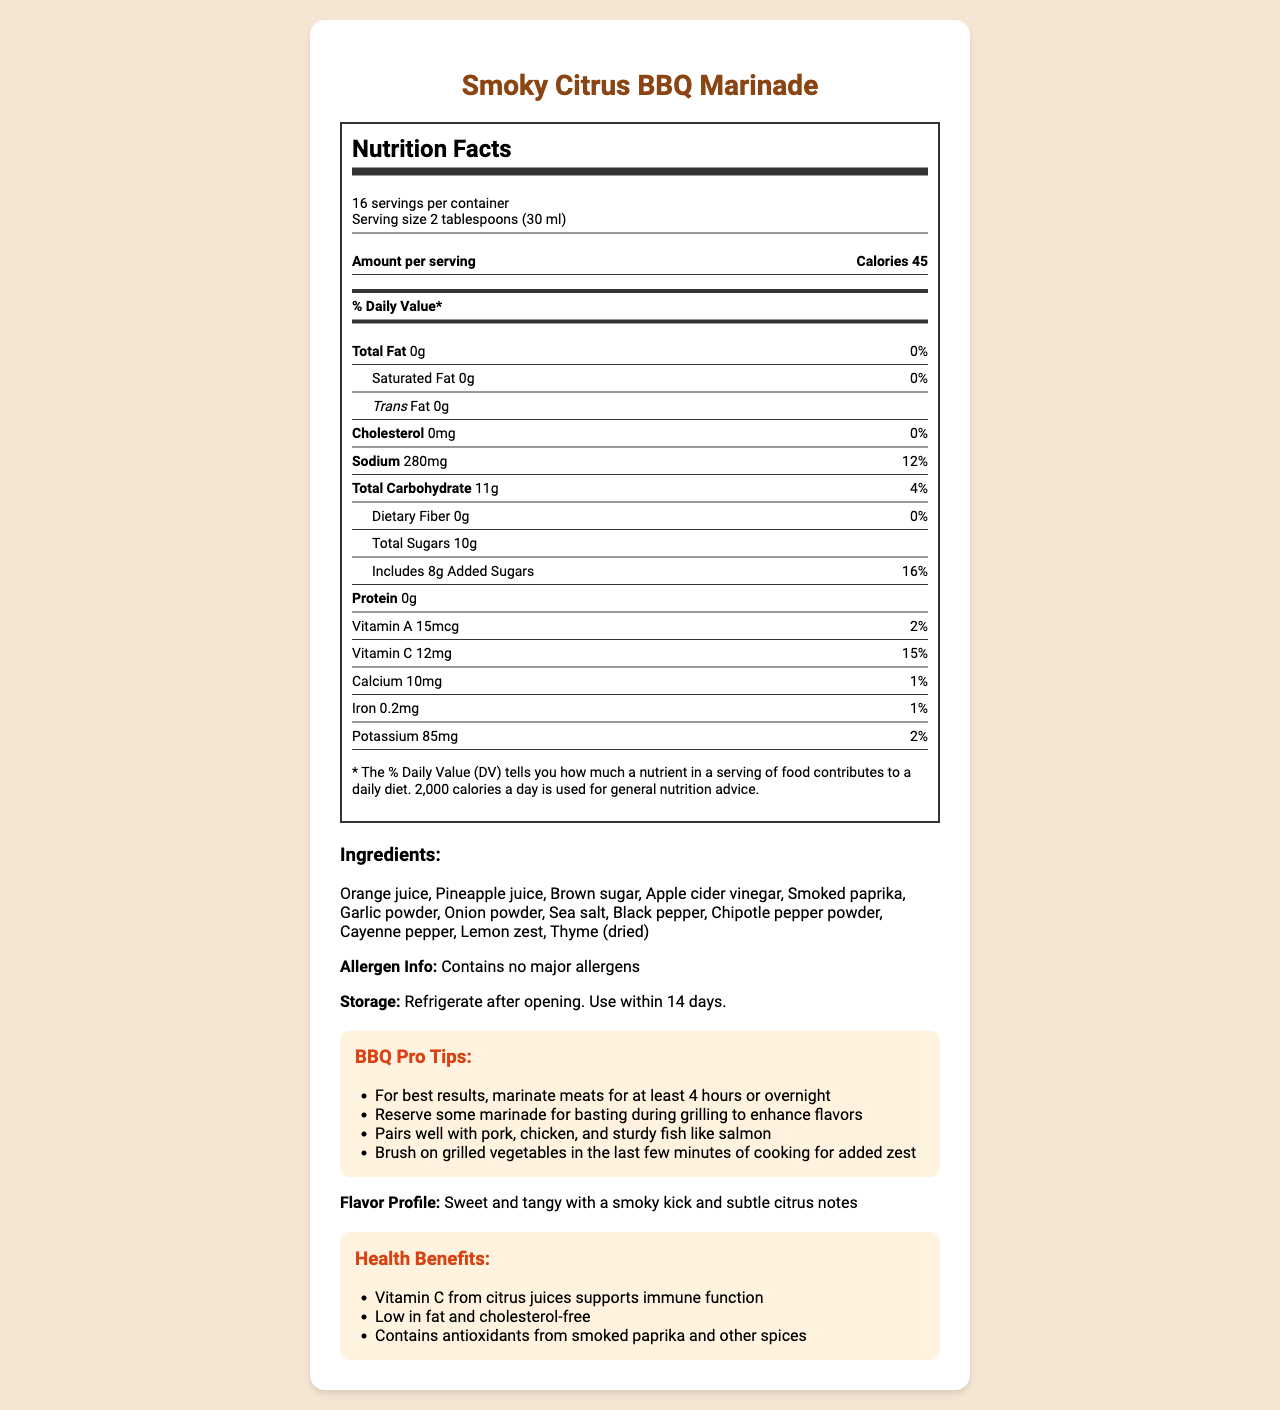what is the serving size of the Smoky Citrus BBQ Marinade? The serving size is clearly stated in the nutrition facts section as "2 tablespoons (30 ml)".
Answer: 2 tablespoons (30 ml) how many servings are there per container? The document lists that there are 16 servings per container right below the title "Nutrition Facts".
Answer: 16 how many calories are there per serving? The calorie count per serving is given as 45 in the "Amount per serving" section.
Answer: 45 what is the total amount of sodium per serving? The sodium content per serving is explicitly stated as 280mg.
Answer: 280mg what is the % daily value of added sugars in one serving? The % daily value for added sugars is listed as 16% in the nutritional information section.
Answer: 16% which vitamins are present in this marinade? A. Vitamin A B. Vitamin C C. Both D. Neither The nutritional information lists both Vitamin A and Vitamin C with their respective amounts and daily values.
Answer: C which ingredient is not listed in the Smoky Citrus BBQ Marinade? 1. Orange juice 2. Peanut butter 3. Cayenne pepper The ingredients section lists all included ingredients, and peanut butter is not one of them.
Answer: 2 is this marinade low in fat? The total fat content is 0g per serving, which qualifies it as low in fat.
Answer: Yes does the marinade contain any major allergens? The allergen information specifies that it contains no major allergens.
Answer: No how should you store the Smoky Citrus BBQ Marinade after opening? The storage instructions explicitly state to refrigerate after opening and use within 14 days.
Answer: Refrigerate after opening. Use within 14 days. summarize the main health benefits of the Smoky Citrus BBQ Marinade The health benefits section mentions the Vitamin C content which supports immune function, being low in fat and cholesterol-free, and containing antioxidants from smoked paprika and other spices.
Answer: Contains Vitamin C which supports immune function, low in fat and cholesterol-free, and contains antioxidants from spices how much dietary fiber is there in one serving? The nutritional information indicates that there is 0g of dietary fiber per serving.
Answer: 0g describe the flavor profile of the Smoky Citrus BBQ Marinade. The flavor profile is described in the document as sweet and tangy with a smoky kick and subtle citrus notes.
Answer: Sweet and tangy with a smoky kick and subtle citrus notes what types of meats does this marinade pair well with? The BBQ tips section advises that it pairs well with pork, chicken, and sturdy fish like salmon.
Answer: Pork, chicken, and sturdy fish like salmon how should you use the marinade for the best grilling results? The tips section suggests marinating meats for at least 4 hours or overnight, and reserving some marinade for basting during grilling.
Answer: Marinate meats for at least 4 hours or overnight, and reserve some marinade for basting during grilling what is the main source of sugars in this marinade? The document does not provide specific information about the exact source of sugars, only the total sugar and added sugars content.
Answer: Cannot be determined 